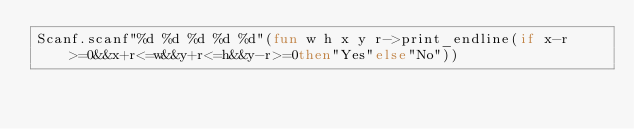<code> <loc_0><loc_0><loc_500><loc_500><_OCaml_>Scanf.scanf"%d %d %d %d %d"(fun w h x y r->print_endline(if x-r>=0&&x+r<=w&&y+r<=h&&y-r>=0then"Yes"else"No"))</code> 